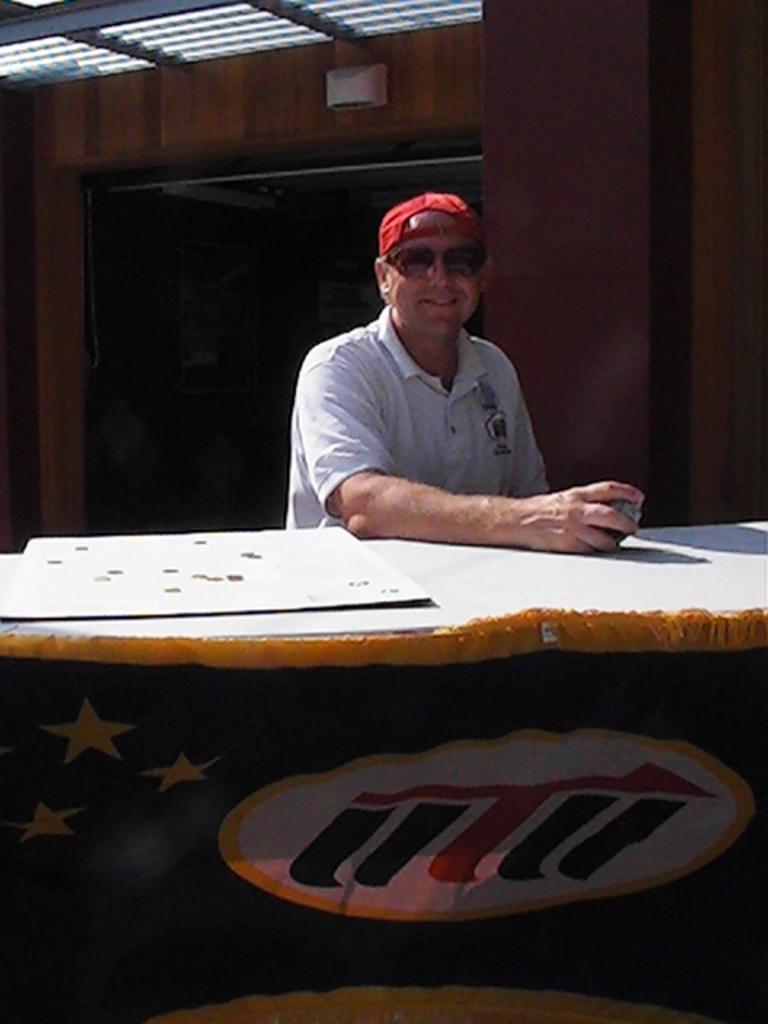Could you give a brief overview of what you see in this image? In this picture there is a man in white shirt and Red Hat sitting on the chair in front of the table on which there is a sheet. 